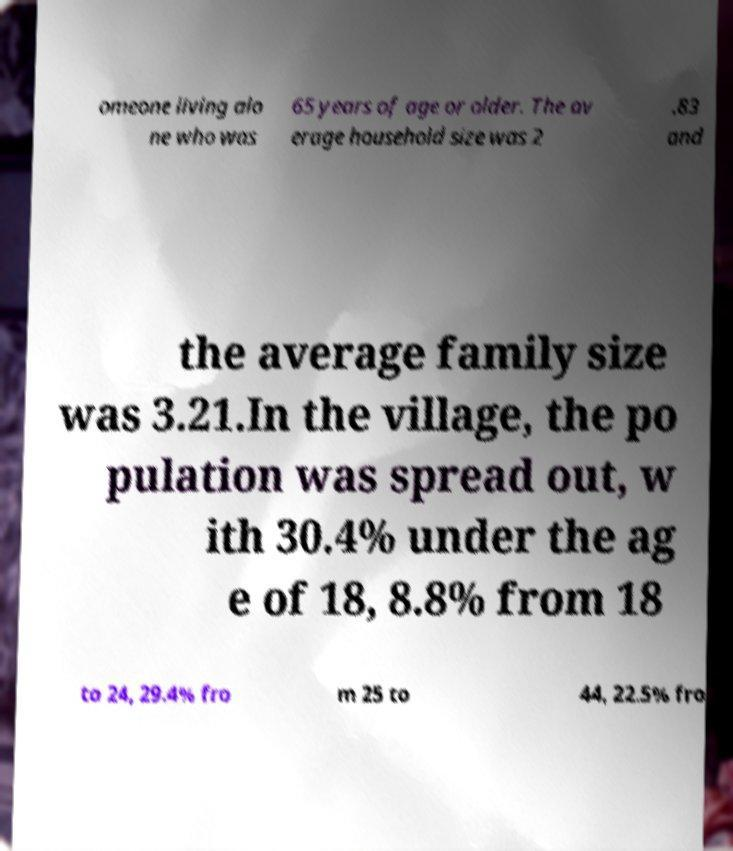Can you read and provide the text displayed in the image?This photo seems to have some interesting text. Can you extract and type it out for me? omeone living alo ne who was 65 years of age or older. The av erage household size was 2 .83 and the average family size was 3.21.In the village, the po pulation was spread out, w ith 30.4% under the ag e of 18, 8.8% from 18 to 24, 29.4% fro m 25 to 44, 22.5% fro 